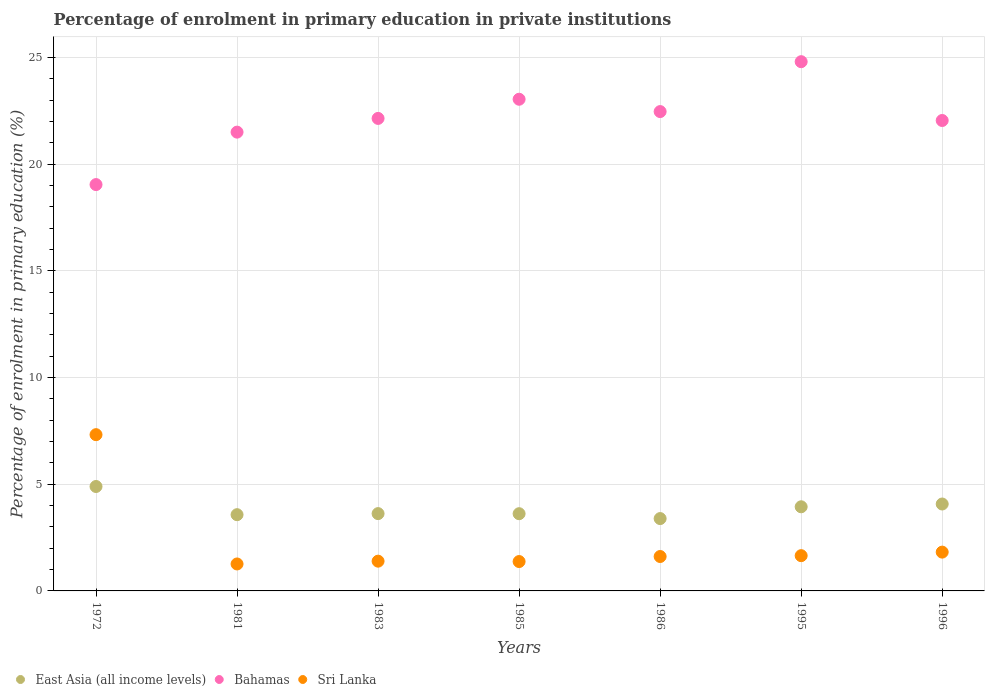What is the percentage of enrolment in primary education in Sri Lanka in 1985?
Keep it short and to the point. 1.38. Across all years, what is the maximum percentage of enrolment in primary education in Sri Lanka?
Your answer should be very brief. 7.32. Across all years, what is the minimum percentage of enrolment in primary education in Bahamas?
Make the answer very short. 19.04. In which year was the percentage of enrolment in primary education in Bahamas maximum?
Give a very brief answer. 1995. In which year was the percentage of enrolment in primary education in Sri Lanka minimum?
Provide a short and direct response. 1981. What is the total percentage of enrolment in primary education in Bahamas in the graph?
Provide a succinct answer. 155.02. What is the difference between the percentage of enrolment in primary education in East Asia (all income levels) in 1981 and that in 1995?
Make the answer very short. -0.37. What is the difference between the percentage of enrolment in primary education in East Asia (all income levels) in 1972 and the percentage of enrolment in primary education in Bahamas in 1986?
Offer a terse response. -17.57. What is the average percentage of enrolment in primary education in East Asia (all income levels) per year?
Ensure brevity in your answer.  3.87. In the year 1985, what is the difference between the percentage of enrolment in primary education in Sri Lanka and percentage of enrolment in primary education in East Asia (all income levels)?
Provide a short and direct response. -2.24. In how many years, is the percentage of enrolment in primary education in East Asia (all income levels) greater than 13 %?
Provide a short and direct response. 0. What is the ratio of the percentage of enrolment in primary education in Bahamas in 1972 to that in 1986?
Your response must be concise. 0.85. What is the difference between the highest and the second highest percentage of enrolment in primary education in Bahamas?
Ensure brevity in your answer.  1.76. What is the difference between the highest and the lowest percentage of enrolment in primary education in Bahamas?
Give a very brief answer. 5.76. In how many years, is the percentage of enrolment in primary education in Sri Lanka greater than the average percentage of enrolment in primary education in Sri Lanka taken over all years?
Give a very brief answer. 1. Is it the case that in every year, the sum of the percentage of enrolment in primary education in East Asia (all income levels) and percentage of enrolment in primary education in Bahamas  is greater than the percentage of enrolment in primary education in Sri Lanka?
Keep it short and to the point. Yes. Does the percentage of enrolment in primary education in Sri Lanka monotonically increase over the years?
Keep it short and to the point. No. Is the percentage of enrolment in primary education in East Asia (all income levels) strictly greater than the percentage of enrolment in primary education in Sri Lanka over the years?
Give a very brief answer. No. Is the percentage of enrolment in primary education in East Asia (all income levels) strictly less than the percentage of enrolment in primary education in Sri Lanka over the years?
Offer a very short reply. No. What is the difference between two consecutive major ticks on the Y-axis?
Your answer should be very brief. 5. Does the graph contain any zero values?
Give a very brief answer. No. Does the graph contain grids?
Your answer should be compact. Yes. Where does the legend appear in the graph?
Your answer should be compact. Bottom left. How many legend labels are there?
Make the answer very short. 3. How are the legend labels stacked?
Offer a very short reply. Horizontal. What is the title of the graph?
Provide a short and direct response. Percentage of enrolment in primary education in private institutions. Does "Tunisia" appear as one of the legend labels in the graph?
Ensure brevity in your answer.  No. What is the label or title of the X-axis?
Keep it short and to the point. Years. What is the label or title of the Y-axis?
Offer a very short reply. Percentage of enrolment in primary education (%). What is the Percentage of enrolment in primary education (%) in East Asia (all income levels) in 1972?
Give a very brief answer. 4.89. What is the Percentage of enrolment in primary education (%) in Bahamas in 1972?
Offer a terse response. 19.04. What is the Percentage of enrolment in primary education (%) in Sri Lanka in 1972?
Offer a very short reply. 7.32. What is the Percentage of enrolment in primary education (%) in East Asia (all income levels) in 1981?
Offer a terse response. 3.57. What is the Percentage of enrolment in primary education (%) of Bahamas in 1981?
Keep it short and to the point. 21.5. What is the Percentage of enrolment in primary education (%) of Sri Lanka in 1981?
Offer a terse response. 1.26. What is the Percentage of enrolment in primary education (%) of East Asia (all income levels) in 1983?
Your response must be concise. 3.62. What is the Percentage of enrolment in primary education (%) of Bahamas in 1983?
Offer a very short reply. 22.14. What is the Percentage of enrolment in primary education (%) of Sri Lanka in 1983?
Offer a very short reply. 1.39. What is the Percentage of enrolment in primary education (%) of East Asia (all income levels) in 1985?
Your answer should be very brief. 3.62. What is the Percentage of enrolment in primary education (%) in Bahamas in 1985?
Offer a terse response. 23.04. What is the Percentage of enrolment in primary education (%) in Sri Lanka in 1985?
Give a very brief answer. 1.38. What is the Percentage of enrolment in primary education (%) of East Asia (all income levels) in 1986?
Your answer should be very brief. 3.39. What is the Percentage of enrolment in primary education (%) of Bahamas in 1986?
Your answer should be very brief. 22.46. What is the Percentage of enrolment in primary education (%) in Sri Lanka in 1986?
Provide a succinct answer. 1.61. What is the Percentage of enrolment in primary education (%) of East Asia (all income levels) in 1995?
Offer a terse response. 3.94. What is the Percentage of enrolment in primary education (%) of Bahamas in 1995?
Provide a succinct answer. 24.8. What is the Percentage of enrolment in primary education (%) in Sri Lanka in 1995?
Your answer should be compact. 1.65. What is the Percentage of enrolment in primary education (%) in East Asia (all income levels) in 1996?
Offer a very short reply. 4.07. What is the Percentage of enrolment in primary education (%) of Bahamas in 1996?
Offer a terse response. 22.04. What is the Percentage of enrolment in primary education (%) of Sri Lanka in 1996?
Provide a short and direct response. 1.82. Across all years, what is the maximum Percentage of enrolment in primary education (%) of East Asia (all income levels)?
Provide a short and direct response. 4.89. Across all years, what is the maximum Percentage of enrolment in primary education (%) of Bahamas?
Give a very brief answer. 24.8. Across all years, what is the maximum Percentage of enrolment in primary education (%) of Sri Lanka?
Give a very brief answer. 7.32. Across all years, what is the minimum Percentage of enrolment in primary education (%) of East Asia (all income levels)?
Your answer should be very brief. 3.39. Across all years, what is the minimum Percentage of enrolment in primary education (%) in Bahamas?
Your response must be concise. 19.04. Across all years, what is the minimum Percentage of enrolment in primary education (%) of Sri Lanka?
Offer a terse response. 1.26. What is the total Percentage of enrolment in primary education (%) in East Asia (all income levels) in the graph?
Provide a succinct answer. 27.11. What is the total Percentage of enrolment in primary education (%) of Bahamas in the graph?
Offer a very short reply. 155.02. What is the total Percentage of enrolment in primary education (%) of Sri Lanka in the graph?
Your answer should be very brief. 16.44. What is the difference between the Percentage of enrolment in primary education (%) of East Asia (all income levels) in 1972 and that in 1981?
Your response must be concise. 1.32. What is the difference between the Percentage of enrolment in primary education (%) in Bahamas in 1972 and that in 1981?
Your answer should be very brief. -2.46. What is the difference between the Percentage of enrolment in primary education (%) of Sri Lanka in 1972 and that in 1981?
Give a very brief answer. 6.06. What is the difference between the Percentage of enrolment in primary education (%) of East Asia (all income levels) in 1972 and that in 1983?
Your response must be concise. 1.27. What is the difference between the Percentage of enrolment in primary education (%) of Bahamas in 1972 and that in 1983?
Offer a very short reply. -3.1. What is the difference between the Percentage of enrolment in primary education (%) of Sri Lanka in 1972 and that in 1983?
Your answer should be compact. 5.93. What is the difference between the Percentage of enrolment in primary education (%) in East Asia (all income levels) in 1972 and that in 1985?
Your answer should be compact. 1.27. What is the difference between the Percentage of enrolment in primary education (%) in Bahamas in 1972 and that in 1985?
Provide a succinct answer. -4. What is the difference between the Percentage of enrolment in primary education (%) in Sri Lanka in 1972 and that in 1985?
Make the answer very short. 5.95. What is the difference between the Percentage of enrolment in primary education (%) in East Asia (all income levels) in 1972 and that in 1986?
Offer a very short reply. 1.5. What is the difference between the Percentage of enrolment in primary education (%) in Bahamas in 1972 and that in 1986?
Your answer should be very brief. -3.42. What is the difference between the Percentage of enrolment in primary education (%) of Sri Lanka in 1972 and that in 1986?
Your answer should be compact. 5.71. What is the difference between the Percentage of enrolment in primary education (%) of East Asia (all income levels) in 1972 and that in 1995?
Offer a terse response. 0.95. What is the difference between the Percentage of enrolment in primary education (%) of Bahamas in 1972 and that in 1995?
Your answer should be compact. -5.76. What is the difference between the Percentage of enrolment in primary education (%) in Sri Lanka in 1972 and that in 1995?
Make the answer very short. 5.67. What is the difference between the Percentage of enrolment in primary education (%) in East Asia (all income levels) in 1972 and that in 1996?
Your answer should be compact. 0.82. What is the difference between the Percentage of enrolment in primary education (%) of Bahamas in 1972 and that in 1996?
Give a very brief answer. -3. What is the difference between the Percentage of enrolment in primary education (%) in Sri Lanka in 1972 and that in 1996?
Your response must be concise. 5.5. What is the difference between the Percentage of enrolment in primary education (%) of East Asia (all income levels) in 1981 and that in 1983?
Offer a terse response. -0.05. What is the difference between the Percentage of enrolment in primary education (%) in Bahamas in 1981 and that in 1983?
Make the answer very short. -0.64. What is the difference between the Percentage of enrolment in primary education (%) of Sri Lanka in 1981 and that in 1983?
Your answer should be very brief. -0.13. What is the difference between the Percentage of enrolment in primary education (%) of East Asia (all income levels) in 1981 and that in 1985?
Give a very brief answer. -0.05. What is the difference between the Percentage of enrolment in primary education (%) of Bahamas in 1981 and that in 1985?
Ensure brevity in your answer.  -1.54. What is the difference between the Percentage of enrolment in primary education (%) in Sri Lanka in 1981 and that in 1985?
Provide a short and direct response. -0.11. What is the difference between the Percentage of enrolment in primary education (%) of East Asia (all income levels) in 1981 and that in 1986?
Offer a terse response. 0.18. What is the difference between the Percentage of enrolment in primary education (%) in Bahamas in 1981 and that in 1986?
Make the answer very short. -0.96. What is the difference between the Percentage of enrolment in primary education (%) of Sri Lanka in 1981 and that in 1986?
Your answer should be compact. -0.35. What is the difference between the Percentage of enrolment in primary education (%) in East Asia (all income levels) in 1981 and that in 1995?
Make the answer very short. -0.37. What is the difference between the Percentage of enrolment in primary education (%) in Bahamas in 1981 and that in 1995?
Make the answer very short. -3.3. What is the difference between the Percentage of enrolment in primary education (%) in Sri Lanka in 1981 and that in 1995?
Give a very brief answer. -0.39. What is the difference between the Percentage of enrolment in primary education (%) of East Asia (all income levels) in 1981 and that in 1996?
Ensure brevity in your answer.  -0.5. What is the difference between the Percentage of enrolment in primary education (%) in Bahamas in 1981 and that in 1996?
Make the answer very short. -0.55. What is the difference between the Percentage of enrolment in primary education (%) of Sri Lanka in 1981 and that in 1996?
Provide a succinct answer. -0.55. What is the difference between the Percentage of enrolment in primary education (%) in East Asia (all income levels) in 1983 and that in 1985?
Your response must be concise. 0. What is the difference between the Percentage of enrolment in primary education (%) in Bahamas in 1983 and that in 1985?
Provide a short and direct response. -0.9. What is the difference between the Percentage of enrolment in primary education (%) in Sri Lanka in 1983 and that in 1985?
Your response must be concise. 0.02. What is the difference between the Percentage of enrolment in primary education (%) in East Asia (all income levels) in 1983 and that in 1986?
Ensure brevity in your answer.  0.23. What is the difference between the Percentage of enrolment in primary education (%) of Bahamas in 1983 and that in 1986?
Ensure brevity in your answer.  -0.32. What is the difference between the Percentage of enrolment in primary education (%) in Sri Lanka in 1983 and that in 1986?
Offer a very short reply. -0.22. What is the difference between the Percentage of enrolment in primary education (%) of East Asia (all income levels) in 1983 and that in 1995?
Give a very brief answer. -0.32. What is the difference between the Percentage of enrolment in primary education (%) in Bahamas in 1983 and that in 1995?
Make the answer very short. -2.66. What is the difference between the Percentage of enrolment in primary education (%) in Sri Lanka in 1983 and that in 1995?
Keep it short and to the point. -0.26. What is the difference between the Percentage of enrolment in primary education (%) in East Asia (all income levels) in 1983 and that in 1996?
Give a very brief answer. -0.45. What is the difference between the Percentage of enrolment in primary education (%) in Bahamas in 1983 and that in 1996?
Keep it short and to the point. 0.1. What is the difference between the Percentage of enrolment in primary education (%) in Sri Lanka in 1983 and that in 1996?
Give a very brief answer. -0.42. What is the difference between the Percentage of enrolment in primary education (%) of East Asia (all income levels) in 1985 and that in 1986?
Your response must be concise. 0.23. What is the difference between the Percentage of enrolment in primary education (%) of Bahamas in 1985 and that in 1986?
Your response must be concise. 0.58. What is the difference between the Percentage of enrolment in primary education (%) in Sri Lanka in 1985 and that in 1986?
Offer a very short reply. -0.24. What is the difference between the Percentage of enrolment in primary education (%) in East Asia (all income levels) in 1985 and that in 1995?
Offer a very short reply. -0.32. What is the difference between the Percentage of enrolment in primary education (%) in Bahamas in 1985 and that in 1995?
Your answer should be very brief. -1.76. What is the difference between the Percentage of enrolment in primary education (%) in Sri Lanka in 1985 and that in 1995?
Make the answer very short. -0.28. What is the difference between the Percentage of enrolment in primary education (%) of East Asia (all income levels) in 1985 and that in 1996?
Ensure brevity in your answer.  -0.45. What is the difference between the Percentage of enrolment in primary education (%) in Bahamas in 1985 and that in 1996?
Provide a succinct answer. 1. What is the difference between the Percentage of enrolment in primary education (%) in Sri Lanka in 1985 and that in 1996?
Make the answer very short. -0.44. What is the difference between the Percentage of enrolment in primary education (%) in East Asia (all income levels) in 1986 and that in 1995?
Your answer should be compact. -0.55. What is the difference between the Percentage of enrolment in primary education (%) of Bahamas in 1986 and that in 1995?
Your answer should be very brief. -2.34. What is the difference between the Percentage of enrolment in primary education (%) in Sri Lanka in 1986 and that in 1995?
Keep it short and to the point. -0.04. What is the difference between the Percentage of enrolment in primary education (%) of East Asia (all income levels) in 1986 and that in 1996?
Make the answer very short. -0.68. What is the difference between the Percentage of enrolment in primary education (%) of Bahamas in 1986 and that in 1996?
Offer a very short reply. 0.42. What is the difference between the Percentage of enrolment in primary education (%) in Sri Lanka in 1986 and that in 1996?
Your answer should be very brief. -0.21. What is the difference between the Percentage of enrolment in primary education (%) of East Asia (all income levels) in 1995 and that in 1996?
Provide a succinct answer. -0.13. What is the difference between the Percentage of enrolment in primary education (%) of Bahamas in 1995 and that in 1996?
Offer a terse response. 2.76. What is the difference between the Percentage of enrolment in primary education (%) of Sri Lanka in 1995 and that in 1996?
Offer a very short reply. -0.17. What is the difference between the Percentage of enrolment in primary education (%) in East Asia (all income levels) in 1972 and the Percentage of enrolment in primary education (%) in Bahamas in 1981?
Provide a succinct answer. -16.6. What is the difference between the Percentage of enrolment in primary education (%) of East Asia (all income levels) in 1972 and the Percentage of enrolment in primary education (%) of Sri Lanka in 1981?
Keep it short and to the point. 3.63. What is the difference between the Percentage of enrolment in primary education (%) of Bahamas in 1972 and the Percentage of enrolment in primary education (%) of Sri Lanka in 1981?
Keep it short and to the point. 17.78. What is the difference between the Percentage of enrolment in primary education (%) in East Asia (all income levels) in 1972 and the Percentage of enrolment in primary education (%) in Bahamas in 1983?
Offer a very short reply. -17.25. What is the difference between the Percentage of enrolment in primary education (%) in East Asia (all income levels) in 1972 and the Percentage of enrolment in primary education (%) in Sri Lanka in 1983?
Offer a very short reply. 3.5. What is the difference between the Percentage of enrolment in primary education (%) of Bahamas in 1972 and the Percentage of enrolment in primary education (%) of Sri Lanka in 1983?
Ensure brevity in your answer.  17.65. What is the difference between the Percentage of enrolment in primary education (%) of East Asia (all income levels) in 1972 and the Percentage of enrolment in primary education (%) of Bahamas in 1985?
Offer a terse response. -18.15. What is the difference between the Percentage of enrolment in primary education (%) of East Asia (all income levels) in 1972 and the Percentage of enrolment in primary education (%) of Sri Lanka in 1985?
Ensure brevity in your answer.  3.52. What is the difference between the Percentage of enrolment in primary education (%) in Bahamas in 1972 and the Percentage of enrolment in primary education (%) in Sri Lanka in 1985?
Provide a succinct answer. 17.66. What is the difference between the Percentage of enrolment in primary education (%) in East Asia (all income levels) in 1972 and the Percentage of enrolment in primary education (%) in Bahamas in 1986?
Provide a succinct answer. -17.57. What is the difference between the Percentage of enrolment in primary education (%) in East Asia (all income levels) in 1972 and the Percentage of enrolment in primary education (%) in Sri Lanka in 1986?
Your answer should be compact. 3.28. What is the difference between the Percentage of enrolment in primary education (%) of Bahamas in 1972 and the Percentage of enrolment in primary education (%) of Sri Lanka in 1986?
Your response must be concise. 17.43. What is the difference between the Percentage of enrolment in primary education (%) of East Asia (all income levels) in 1972 and the Percentage of enrolment in primary education (%) of Bahamas in 1995?
Offer a very short reply. -19.91. What is the difference between the Percentage of enrolment in primary education (%) of East Asia (all income levels) in 1972 and the Percentage of enrolment in primary education (%) of Sri Lanka in 1995?
Your response must be concise. 3.24. What is the difference between the Percentage of enrolment in primary education (%) in Bahamas in 1972 and the Percentage of enrolment in primary education (%) in Sri Lanka in 1995?
Provide a short and direct response. 17.39. What is the difference between the Percentage of enrolment in primary education (%) of East Asia (all income levels) in 1972 and the Percentage of enrolment in primary education (%) of Bahamas in 1996?
Provide a short and direct response. -17.15. What is the difference between the Percentage of enrolment in primary education (%) in East Asia (all income levels) in 1972 and the Percentage of enrolment in primary education (%) in Sri Lanka in 1996?
Your answer should be very brief. 3.08. What is the difference between the Percentage of enrolment in primary education (%) in Bahamas in 1972 and the Percentage of enrolment in primary education (%) in Sri Lanka in 1996?
Offer a very short reply. 17.22. What is the difference between the Percentage of enrolment in primary education (%) of East Asia (all income levels) in 1981 and the Percentage of enrolment in primary education (%) of Bahamas in 1983?
Your answer should be compact. -18.57. What is the difference between the Percentage of enrolment in primary education (%) in East Asia (all income levels) in 1981 and the Percentage of enrolment in primary education (%) in Sri Lanka in 1983?
Ensure brevity in your answer.  2.18. What is the difference between the Percentage of enrolment in primary education (%) of Bahamas in 1981 and the Percentage of enrolment in primary education (%) of Sri Lanka in 1983?
Make the answer very short. 20.1. What is the difference between the Percentage of enrolment in primary education (%) of East Asia (all income levels) in 1981 and the Percentage of enrolment in primary education (%) of Bahamas in 1985?
Your response must be concise. -19.47. What is the difference between the Percentage of enrolment in primary education (%) in East Asia (all income levels) in 1981 and the Percentage of enrolment in primary education (%) in Sri Lanka in 1985?
Provide a short and direct response. 2.2. What is the difference between the Percentage of enrolment in primary education (%) in Bahamas in 1981 and the Percentage of enrolment in primary education (%) in Sri Lanka in 1985?
Make the answer very short. 20.12. What is the difference between the Percentage of enrolment in primary education (%) in East Asia (all income levels) in 1981 and the Percentage of enrolment in primary education (%) in Bahamas in 1986?
Offer a very short reply. -18.89. What is the difference between the Percentage of enrolment in primary education (%) of East Asia (all income levels) in 1981 and the Percentage of enrolment in primary education (%) of Sri Lanka in 1986?
Your response must be concise. 1.96. What is the difference between the Percentage of enrolment in primary education (%) of Bahamas in 1981 and the Percentage of enrolment in primary education (%) of Sri Lanka in 1986?
Your answer should be very brief. 19.89. What is the difference between the Percentage of enrolment in primary education (%) in East Asia (all income levels) in 1981 and the Percentage of enrolment in primary education (%) in Bahamas in 1995?
Your answer should be very brief. -21.23. What is the difference between the Percentage of enrolment in primary education (%) in East Asia (all income levels) in 1981 and the Percentage of enrolment in primary education (%) in Sri Lanka in 1995?
Keep it short and to the point. 1.92. What is the difference between the Percentage of enrolment in primary education (%) in Bahamas in 1981 and the Percentage of enrolment in primary education (%) in Sri Lanka in 1995?
Provide a succinct answer. 19.85. What is the difference between the Percentage of enrolment in primary education (%) in East Asia (all income levels) in 1981 and the Percentage of enrolment in primary education (%) in Bahamas in 1996?
Your answer should be very brief. -18.47. What is the difference between the Percentage of enrolment in primary education (%) in East Asia (all income levels) in 1981 and the Percentage of enrolment in primary education (%) in Sri Lanka in 1996?
Keep it short and to the point. 1.75. What is the difference between the Percentage of enrolment in primary education (%) of Bahamas in 1981 and the Percentage of enrolment in primary education (%) of Sri Lanka in 1996?
Ensure brevity in your answer.  19.68. What is the difference between the Percentage of enrolment in primary education (%) in East Asia (all income levels) in 1983 and the Percentage of enrolment in primary education (%) in Bahamas in 1985?
Provide a short and direct response. -19.42. What is the difference between the Percentage of enrolment in primary education (%) in East Asia (all income levels) in 1983 and the Percentage of enrolment in primary education (%) in Sri Lanka in 1985?
Your answer should be very brief. 2.25. What is the difference between the Percentage of enrolment in primary education (%) of Bahamas in 1983 and the Percentage of enrolment in primary education (%) of Sri Lanka in 1985?
Make the answer very short. 20.76. What is the difference between the Percentage of enrolment in primary education (%) in East Asia (all income levels) in 1983 and the Percentage of enrolment in primary education (%) in Bahamas in 1986?
Your answer should be compact. -18.84. What is the difference between the Percentage of enrolment in primary education (%) of East Asia (all income levels) in 1983 and the Percentage of enrolment in primary education (%) of Sri Lanka in 1986?
Provide a succinct answer. 2.01. What is the difference between the Percentage of enrolment in primary education (%) of Bahamas in 1983 and the Percentage of enrolment in primary education (%) of Sri Lanka in 1986?
Keep it short and to the point. 20.53. What is the difference between the Percentage of enrolment in primary education (%) in East Asia (all income levels) in 1983 and the Percentage of enrolment in primary education (%) in Bahamas in 1995?
Provide a short and direct response. -21.18. What is the difference between the Percentage of enrolment in primary education (%) in East Asia (all income levels) in 1983 and the Percentage of enrolment in primary education (%) in Sri Lanka in 1995?
Give a very brief answer. 1.97. What is the difference between the Percentage of enrolment in primary education (%) in Bahamas in 1983 and the Percentage of enrolment in primary education (%) in Sri Lanka in 1995?
Keep it short and to the point. 20.49. What is the difference between the Percentage of enrolment in primary education (%) in East Asia (all income levels) in 1983 and the Percentage of enrolment in primary education (%) in Bahamas in 1996?
Ensure brevity in your answer.  -18.42. What is the difference between the Percentage of enrolment in primary education (%) of East Asia (all income levels) in 1983 and the Percentage of enrolment in primary education (%) of Sri Lanka in 1996?
Provide a succinct answer. 1.8. What is the difference between the Percentage of enrolment in primary education (%) in Bahamas in 1983 and the Percentage of enrolment in primary education (%) in Sri Lanka in 1996?
Give a very brief answer. 20.32. What is the difference between the Percentage of enrolment in primary education (%) in East Asia (all income levels) in 1985 and the Percentage of enrolment in primary education (%) in Bahamas in 1986?
Give a very brief answer. -18.84. What is the difference between the Percentage of enrolment in primary education (%) in East Asia (all income levels) in 1985 and the Percentage of enrolment in primary education (%) in Sri Lanka in 1986?
Ensure brevity in your answer.  2.01. What is the difference between the Percentage of enrolment in primary education (%) in Bahamas in 1985 and the Percentage of enrolment in primary education (%) in Sri Lanka in 1986?
Keep it short and to the point. 21.43. What is the difference between the Percentage of enrolment in primary education (%) in East Asia (all income levels) in 1985 and the Percentage of enrolment in primary education (%) in Bahamas in 1995?
Make the answer very short. -21.18. What is the difference between the Percentage of enrolment in primary education (%) in East Asia (all income levels) in 1985 and the Percentage of enrolment in primary education (%) in Sri Lanka in 1995?
Offer a very short reply. 1.97. What is the difference between the Percentage of enrolment in primary education (%) of Bahamas in 1985 and the Percentage of enrolment in primary education (%) of Sri Lanka in 1995?
Your answer should be very brief. 21.39. What is the difference between the Percentage of enrolment in primary education (%) in East Asia (all income levels) in 1985 and the Percentage of enrolment in primary education (%) in Bahamas in 1996?
Ensure brevity in your answer.  -18.42. What is the difference between the Percentage of enrolment in primary education (%) of East Asia (all income levels) in 1985 and the Percentage of enrolment in primary education (%) of Sri Lanka in 1996?
Provide a succinct answer. 1.8. What is the difference between the Percentage of enrolment in primary education (%) in Bahamas in 1985 and the Percentage of enrolment in primary education (%) in Sri Lanka in 1996?
Provide a succinct answer. 21.22. What is the difference between the Percentage of enrolment in primary education (%) in East Asia (all income levels) in 1986 and the Percentage of enrolment in primary education (%) in Bahamas in 1995?
Your response must be concise. -21.41. What is the difference between the Percentage of enrolment in primary education (%) of East Asia (all income levels) in 1986 and the Percentage of enrolment in primary education (%) of Sri Lanka in 1995?
Your answer should be very brief. 1.74. What is the difference between the Percentage of enrolment in primary education (%) of Bahamas in 1986 and the Percentage of enrolment in primary education (%) of Sri Lanka in 1995?
Provide a short and direct response. 20.81. What is the difference between the Percentage of enrolment in primary education (%) of East Asia (all income levels) in 1986 and the Percentage of enrolment in primary education (%) of Bahamas in 1996?
Make the answer very short. -18.65. What is the difference between the Percentage of enrolment in primary education (%) of East Asia (all income levels) in 1986 and the Percentage of enrolment in primary education (%) of Sri Lanka in 1996?
Provide a short and direct response. 1.57. What is the difference between the Percentage of enrolment in primary education (%) of Bahamas in 1986 and the Percentage of enrolment in primary education (%) of Sri Lanka in 1996?
Keep it short and to the point. 20.64. What is the difference between the Percentage of enrolment in primary education (%) in East Asia (all income levels) in 1995 and the Percentage of enrolment in primary education (%) in Bahamas in 1996?
Keep it short and to the point. -18.1. What is the difference between the Percentage of enrolment in primary education (%) of East Asia (all income levels) in 1995 and the Percentage of enrolment in primary education (%) of Sri Lanka in 1996?
Give a very brief answer. 2.12. What is the difference between the Percentage of enrolment in primary education (%) in Bahamas in 1995 and the Percentage of enrolment in primary education (%) in Sri Lanka in 1996?
Your answer should be very brief. 22.98. What is the average Percentage of enrolment in primary education (%) in East Asia (all income levels) per year?
Your answer should be very brief. 3.87. What is the average Percentage of enrolment in primary education (%) of Bahamas per year?
Ensure brevity in your answer.  22.15. What is the average Percentage of enrolment in primary education (%) of Sri Lanka per year?
Make the answer very short. 2.35. In the year 1972, what is the difference between the Percentage of enrolment in primary education (%) of East Asia (all income levels) and Percentage of enrolment in primary education (%) of Bahamas?
Make the answer very short. -14.15. In the year 1972, what is the difference between the Percentage of enrolment in primary education (%) in East Asia (all income levels) and Percentage of enrolment in primary education (%) in Sri Lanka?
Provide a succinct answer. -2.43. In the year 1972, what is the difference between the Percentage of enrolment in primary education (%) of Bahamas and Percentage of enrolment in primary education (%) of Sri Lanka?
Make the answer very short. 11.72. In the year 1981, what is the difference between the Percentage of enrolment in primary education (%) of East Asia (all income levels) and Percentage of enrolment in primary education (%) of Bahamas?
Make the answer very short. -17.93. In the year 1981, what is the difference between the Percentage of enrolment in primary education (%) in East Asia (all income levels) and Percentage of enrolment in primary education (%) in Sri Lanka?
Provide a succinct answer. 2.31. In the year 1981, what is the difference between the Percentage of enrolment in primary education (%) in Bahamas and Percentage of enrolment in primary education (%) in Sri Lanka?
Your answer should be compact. 20.23. In the year 1983, what is the difference between the Percentage of enrolment in primary education (%) of East Asia (all income levels) and Percentage of enrolment in primary education (%) of Bahamas?
Ensure brevity in your answer.  -18.52. In the year 1983, what is the difference between the Percentage of enrolment in primary education (%) of East Asia (all income levels) and Percentage of enrolment in primary education (%) of Sri Lanka?
Keep it short and to the point. 2.23. In the year 1983, what is the difference between the Percentage of enrolment in primary education (%) in Bahamas and Percentage of enrolment in primary education (%) in Sri Lanka?
Your response must be concise. 20.75. In the year 1985, what is the difference between the Percentage of enrolment in primary education (%) in East Asia (all income levels) and Percentage of enrolment in primary education (%) in Bahamas?
Offer a very short reply. -19.42. In the year 1985, what is the difference between the Percentage of enrolment in primary education (%) of East Asia (all income levels) and Percentage of enrolment in primary education (%) of Sri Lanka?
Your answer should be compact. 2.24. In the year 1985, what is the difference between the Percentage of enrolment in primary education (%) of Bahamas and Percentage of enrolment in primary education (%) of Sri Lanka?
Give a very brief answer. 21.66. In the year 1986, what is the difference between the Percentage of enrolment in primary education (%) of East Asia (all income levels) and Percentage of enrolment in primary education (%) of Bahamas?
Your response must be concise. -19.07. In the year 1986, what is the difference between the Percentage of enrolment in primary education (%) in East Asia (all income levels) and Percentage of enrolment in primary education (%) in Sri Lanka?
Your response must be concise. 1.78. In the year 1986, what is the difference between the Percentage of enrolment in primary education (%) of Bahamas and Percentage of enrolment in primary education (%) of Sri Lanka?
Your response must be concise. 20.85. In the year 1995, what is the difference between the Percentage of enrolment in primary education (%) of East Asia (all income levels) and Percentage of enrolment in primary education (%) of Bahamas?
Offer a very short reply. -20.86. In the year 1995, what is the difference between the Percentage of enrolment in primary education (%) of East Asia (all income levels) and Percentage of enrolment in primary education (%) of Sri Lanka?
Provide a succinct answer. 2.29. In the year 1995, what is the difference between the Percentage of enrolment in primary education (%) in Bahamas and Percentage of enrolment in primary education (%) in Sri Lanka?
Your answer should be compact. 23.15. In the year 1996, what is the difference between the Percentage of enrolment in primary education (%) in East Asia (all income levels) and Percentage of enrolment in primary education (%) in Bahamas?
Keep it short and to the point. -17.97. In the year 1996, what is the difference between the Percentage of enrolment in primary education (%) of East Asia (all income levels) and Percentage of enrolment in primary education (%) of Sri Lanka?
Provide a succinct answer. 2.25. In the year 1996, what is the difference between the Percentage of enrolment in primary education (%) in Bahamas and Percentage of enrolment in primary education (%) in Sri Lanka?
Give a very brief answer. 20.23. What is the ratio of the Percentage of enrolment in primary education (%) in East Asia (all income levels) in 1972 to that in 1981?
Provide a succinct answer. 1.37. What is the ratio of the Percentage of enrolment in primary education (%) of Bahamas in 1972 to that in 1981?
Offer a very short reply. 0.89. What is the ratio of the Percentage of enrolment in primary education (%) in Sri Lanka in 1972 to that in 1981?
Offer a very short reply. 5.8. What is the ratio of the Percentage of enrolment in primary education (%) of East Asia (all income levels) in 1972 to that in 1983?
Provide a short and direct response. 1.35. What is the ratio of the Percentage of enrolment in primary education (%) in Bahamas in 1972 to that in 1983?
Offer a very short reply. 0.86. What is the ratio of the Percentage of enrolment in primary education (%) in Sri Lanka in 1972 to that in 1983?
Provide a short and direct response. 5.25. What is the ratio of the Percentage of enrolment in primary education (%) of East Asia (all income levels) in 1972 to that in 1985?
Offer a terse response. 1.35. What is the ratio of the Percentage of enrolment in primary education (%) in Bahamas in 1972 to that in 1985?
Give a very brief answer. 0.83. What is the ratio of the Percentage of enrolment in primary education (%) in Sri Lanka in 1972 to that in 1985?
Provide a short and direct response. 5.32. What is the ratio of the Percentage of enrolment in primary education (%) in East Asia (all income levels) in 1972 to that in 1986?
Keep it short and to the point. 1.44. What is the ratio of the Percentage of enrolment in primary education (%) of Bahamas in 1972 to that in 1986?
Make the answer very short. 0.85. What is the ratio of the Percentage of enrolment in primary education (%) of Sri Lanka in 1972 to that in 1986?
Provide a succinct answer. 4.54. What is the ratio of the Percentage of enrolment in primary education (%) in East Asia (all income levels) in 1972 to that in 1995?
Provide a succinct answer. 1.24. What is the ratio of the Percentage of enrolment in primary education (%) in Bahamas in 1972 to that in 1995?
Ensure brevity in your answer.  0.77. What is the ratio of the Percentage of enrolment in primary education (%) of Sri Lanka in 1972 to that in 1995?
Your response must be concise. 4.43. What is the ratio of the Percentage of enrolment in primary education (%) of East Asia (all income levels) in 1972 to that in 1996?
Your answer should be very brief. 1.2. What is the ratio of the Percentage of enrolment in primary education (%) of Bahamas in 1972 to that in 1996?
Offer a very short reply. 0.86. What is the ratio of the Percentage of enrolment in primary education (%) of Sri Lanka in 1972 to that in 1996?
Your answer should be compact. 4.03. What is the ratio of the Percentage of enrolment in primary education (%) of East Asia (all income levels) in 1981 to that in 1983?
Provide a succinct answer. 0.99. What is the ratio of the Percentage of enrolment in primary education (%) in Bahamas in 1981 to that in 1983?
Make the answer very short. 0.97. What is the ratio of the Percentage of enrolment in primary education (%) in Sri Lanka in 1981 to that in 1983?
Your response must be concise. 0.91. What is the ratio of the Percentage of enrolment in primary education (%) in East Asia (all income levels) in 1981 to that in 1985?
Your answer should be compact. 0.99. What is the ratio of the Percentage of enrolment in primary education (%) in Bahamas in 1981 to that in 1985?
Your response must be concise. 0.93. What is the ratio of the Percentage of enrolment in primary education (%) of Sri Lanka in 1981 to that in 1985?
Keep it short and to the point. 0.92. What is the ratio of the Percentage of enrolment in primary education (%) in East Asia (all income levels) in 1981 to that in 1986?
Your answer should be very brief. 1.05. What is the ratio of the Percentage of enrolment in primary education (%) of Bahamas in 1981 to that in 1986?
Make the answer very short. 0.96. What is the ratio of the Percentage of enrolment in primary education (%) in Sri Lanka in 1981 to that in 1986?
Your answer should be very brief. 0.78. What is the ratio of the Percentage of enrolment in primary education (%) of East Asia (all income levels) in 1981 to that in 1995?
Your answer should be compact. 0.91. What is the ratio of the Percentage of enrolment in primary education (%) in Bahamas in 1981 to that in 1995?
Keep it short and to the point. 0.87. What is the ratio of the Percentage of enrolment in primary education (%) in Sri Lanka in 1981 to that in 1995?
Your answer should be very brief. 0.76. What is the ratio of the Percentage of enrolment in primary education (%) of East Asia (all income levels) in 1981 to that in 1996?
Keep it short and to the point. 0.88. What is the ratio of the Percentage of enrolment in primary education (%) of Bahamas in 1981 to that in 1996?
Your answer should be compact. 0.98. What is the ratio of the Percentage of enrolment in primary education (%) of Sri Lanka in 1981 to that in 1996?
Offer a very short reply. 0.69. What is the ratio of the Percentage of enrolment in primary education (%) in East Asia (all income levels) in 1983 to that in 1985?
Make the answer very short. 1. What is the ratio of the Percentage of enrolment in primary education (%) of Bahamas in 1983 to that in 1985?
Offer a very short reply. 0.96. What is the ratio of the Percentage of enrolment in primary education (%) in Sri Lanka in 1983 to that in 1985?
Give a very brief answer. 1.01. What is the ratio of the Percentage of enrolment in primary education (%) of East Asia (all income levels) in 1983 to that in 1986?
Your answer should be compact. 1.07. What is the ratio of the Percentage of enrolment in primary education (%) of Bahamas in 1983 to that in 1986?
Keep it short and to the point. 0.99. What is the ratio of the Percentage of enrolment in primary education (%) of Sri Lanka in 1983 to that in 1986?
Ensure brevity in your answer.  0.86. What is the ratio of the Percentage of enrolment in primary education (%) of East Asia (all income levels) in 1983 to that in 1995?
Offer a terse response. 0.92. What is the ratio of the Percentage of enrolment in primary education (%) of Bahamas in 1983 to that in 1995?
Your answer should be compact. 0.89. What is the ratio of the Percentage of enrolment in primary education (%) of Sri Lanka in 1983 to that in 1995?
Keep it short and to the point. 0.84. What is the ratio of the Percentage of enrolment in primary education (%) in East Asia (all income levels) in 1983 to that in 1996?
Ensure brevity in your answer.  0.89. What is the ratio of the Percentage of enrolment in primary education (%) in Sri Lanka in 1983 to that in 1996?
Ensure brevity in your answer.  0.77. What is the ratio of the Percentage of enrolment in primary education (%) of East Asia (all income levels) in 1985 to that in 1986?
Your answer should be compact. 1.07. What is the ratio of the Percentage of enrolment in primary education (%) of Bahamas in 1985 to that in 1986?
Your answer should be compact. 1.03. What is the ratio of the Percentage of enrolment in primary education (%) of Sri Lanka in 1985 to that in 1986?
Your answer should be compact. 0.85. What is the ratio of the Percentage of enrolment in primary education (%) of East Asia (all income levels) in 1985 to that in 1995?
Provide a short and direct response. 0.92. What is the ratio of the Percentage of enrolment in primary education (%) of Bahamas in 1985 to that in 1995?
Provide a short and direct response. 0.93. What is the ratio of the Percentage of enrolment in primary education (%) in Sri Lanka in 1985 to that in 1995?
Provide a short and direct response. 0.83. What is the ratio of the Percentage of enrolment in primary education (%) of East Asia (all income levels) in 1985 to that in 1996?
Make the answer very short. 0.89. What is the ratio of the Percentage of enrolment in primary education (%) of Bahamas in 1985 to that in 1996?
Provide a succinct answer. 1.05. What is the ratio of the Percentage of enrolment in primary education (%) of Sri Lanka in 1985 to that in 1996?
Your response must be concise. 0.76. What is the ratio of the Percentage of enrolment in primary education (%) in East Asia (all income levels) in 1986 to that in 1995?
Provide a succinct answer. 0.86. What is the ratio of the Percentage of enrolment in primary education (%) of Bahamas in 1986 to that in 1995?
Make the answer very short. 0.91. What is the ratio of the Percentage of enrolment in primary education (%) of East Asia (all income levels) in 1986 to that in 1996?
Your answer should be compact. 0.83. What is the ratio of the Percentage of enrolment in primary education (%) in Sri Lanka in 1986 to that in 1996?
Your response must be concise. 0.89. What is the ratio of the Percentage of enrolment in primary education (%) in East Asia (all income levels) in 1995 to that in 1996?
Provide a succinct answer. 0.97. What is the ratio of the Percentage of enrolment in primary education (%) in Bahamas in 1995 to that in 1996?
Make the answer very short. 1.12. What is the ratio of the Percentage of enrolment in primary education (%) in Sri Lanka in 1995 to that in 1996?
Your answer should be very brief. 0.91. What is the difference between the highest and the second highest Percentage of enrolment in primary education (%) of East Asia (all income levels)?
Your answer should be compact. 0.82. What is the difference between the highest and the second highest Percentage of enrolment in primary education (%) in Bahamas?
Provide a succinct answer. 1.76. What is the difference between the highest and the second highest Percentage of enrolment in primary education (%) of Sri Lanka?
Your answer should be very brief. 5.5. What is the difference between the highest and the lowest Percentage of enrolment in primary education (%) of East Asia (all income levels)?
Provide a succinct answer. 1.5. What is the difference between the highest and the lowest Percentage of enrolment in primary education (%) of Bahamas?
Offer a terse response. 5.76. What is the difference between the highest and the lowest Percentage of enrolment in primary education (%) in Sri Lanka?
Keep it short and to the point. 6.06. 